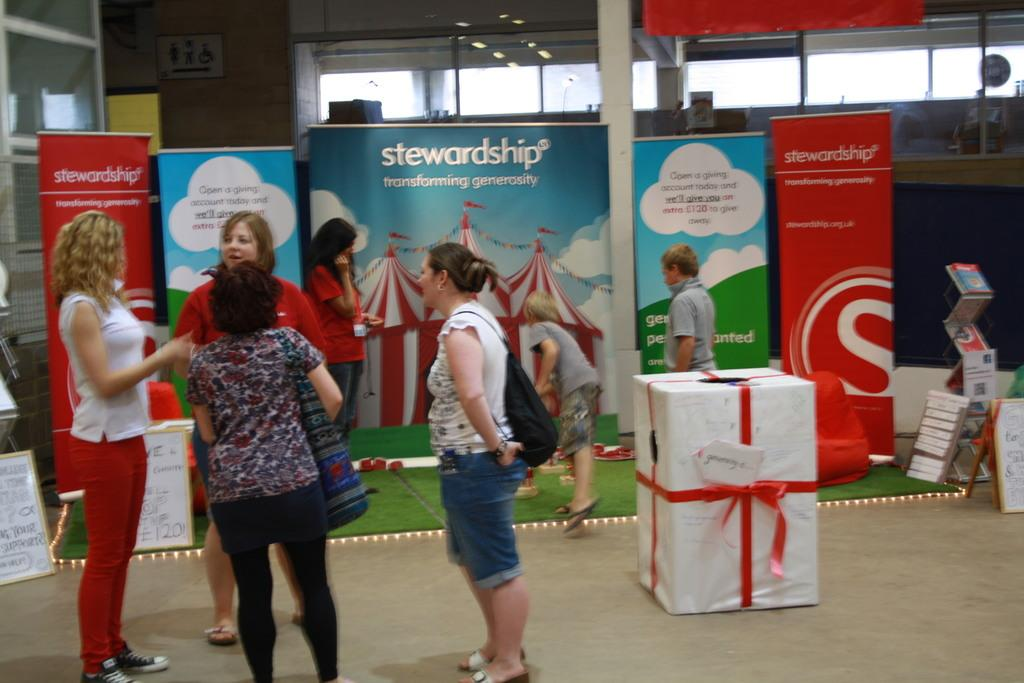<image>
Create a compact narrative representing the image presented. Four women are chatting in-front of a booth that reads "stewardship". 